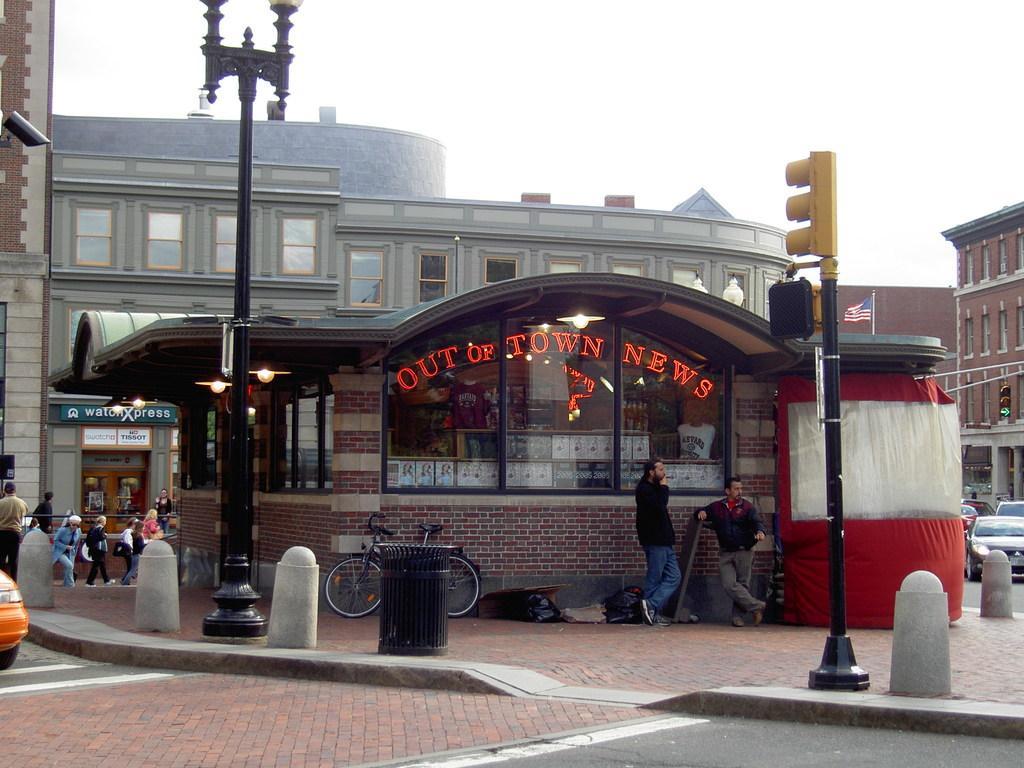Can you describe this image briefly? This image is clicked on the roads. In the front there is a building. There are many people in this image. To the left, there is a car. To the right, there are many cars on the road. In the front there is a bicycle. 